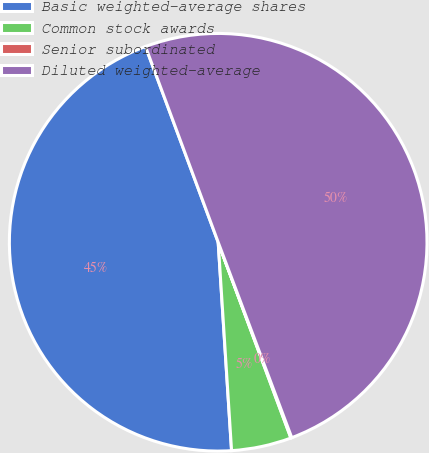Convert chart. <chart><loc_0><loc_0><loc_500><loc_500><pie_chart><fcel>Basic weighted-average shares<fcel>Common stock awards<fcel>Senior subordinated<fcel>Diluted weighted-average<nl><fcel>45.36%<fcel>4.64%<fcel>0.07%<fcel>49.93%<nl></chart> 